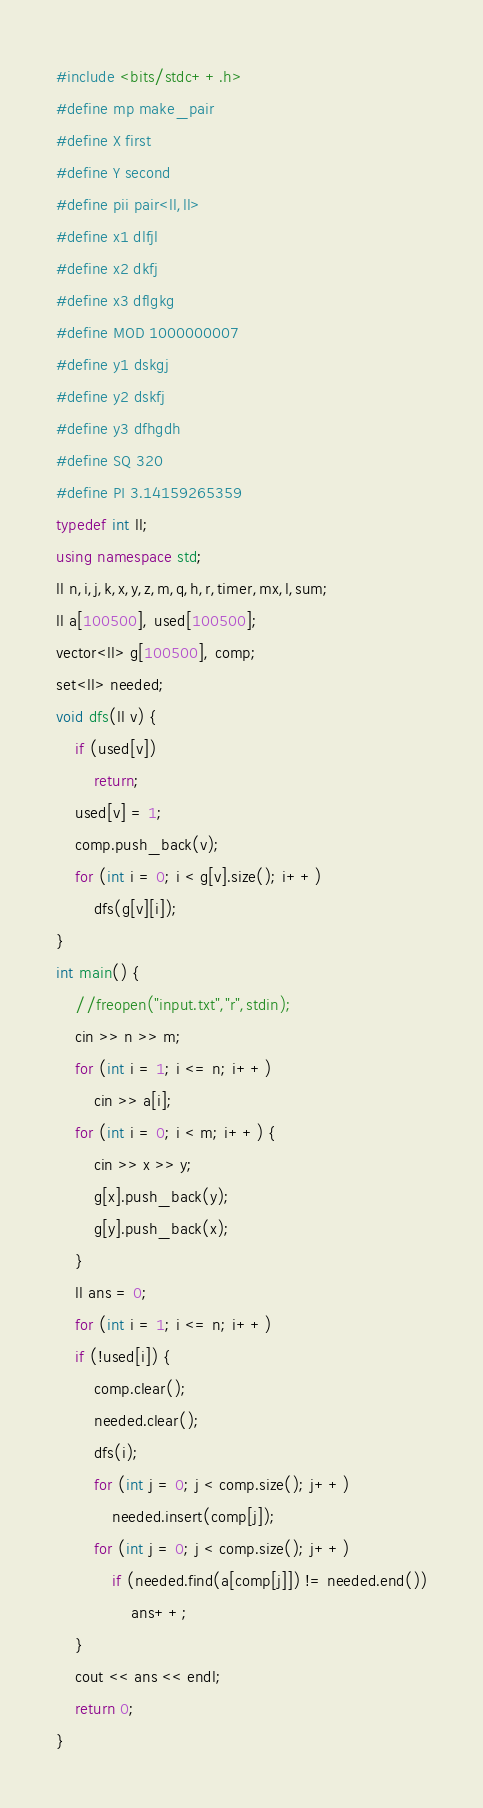<code> <loc_0><loc_0><loc_500><loc_500><_C++_>#include <bits/stdc++.h>
#define mp make_pair
#define X first
#define Y second
#define pii pair<ll,ll>
#define x1 dlfjl
#define x2 dkfj
#define x3 dflgkg
#define MOD 1000000007
#define y1 dskgj
#define y2 dskfj
#define y3 dfhgdh
#define SQ 320
#define PI 3.14159265359
typedef int ll;
using namespace std;
ll n,i,j,k,x,y,z,m,q,h,r,timer,mx,l,sum;
ll a[100500], used[100500];
vector<ll> g[100500], comp;
set<ll> needed;
void dfs(ll v) {
    if (used[v])
        return;
    used[v] = 1;
    comp.push_back(v);
    for (int i = 0; i < g[v].size(); i++)
        dfs(g[v][i]);
}
int main() {
    //freopen("input.txt","r",stdin);
    cin >> n >> m;
    for (int i = 1; i <= n; i++)
        cin >> a[i];
    for (int i = 0; i < m; i++) {
        cin >> x >> y;
        g[x].push_back(y);
        g[y].push_back(x);
    }
    ll ans = 0;
    for (int i = 1; i <= n; i++)
    if (!used[i]) {
        comp.clear();
        needed.clear();
        dfs(i);
        for (int j = 0; j < comp.size(); j++)
            needed.insert(comp[j]);
        for (int j = 0; j < comp.size(); j++)
            if (needed.find(a[comp[j]]) != needed.end())
                ans++;
    }
    cout << ans << endl;
    return 0;
}
</code> 